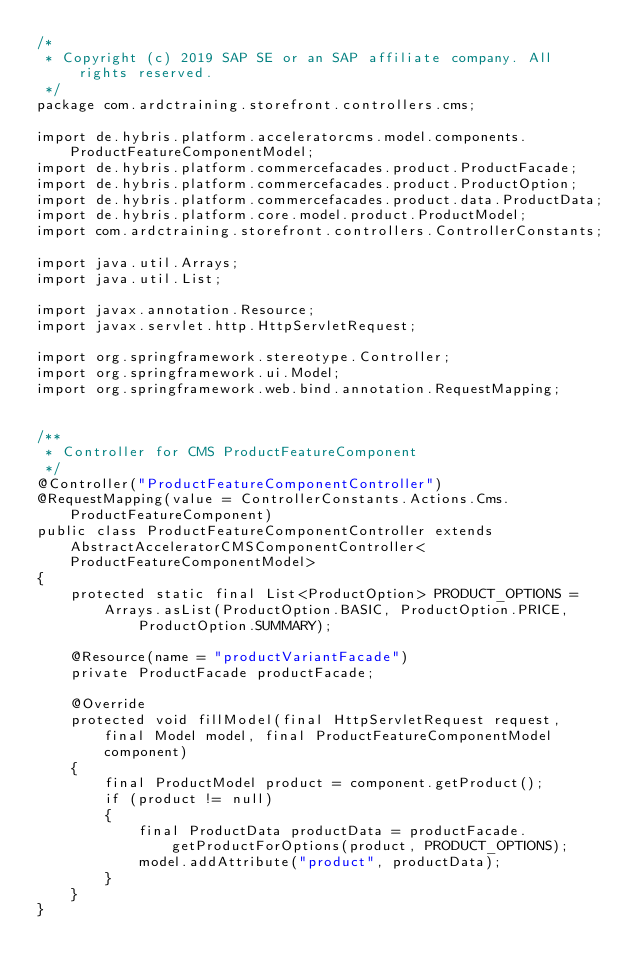Convert code to text. <code><loc_0><loc_0><loc_500><loc_500><_Java_>/*
 * Copyright (c) 2019 SAP SE or an SAP affiliate company. All rights reserved.
 */
package com.ardctraining.storefront.controllers.cms;

import de.hybris.platform.acceleratorcms.model.components.ProductFeatureComponentModel;
import de.hybris.platform.commercefacades.product.ProductFacade;
import de.hybris.platform.commercefacades.product.ProductOption;
import de.hybris.platform.commercefacades.product.data.ProductData;
import de.hybris.platform.core.model.product.ProductModel;
import com.ardctraining.storefront.controllers.ControllerConstants;

import java.util.Arrays;
import java.util.List;

import javax.annotation.Resource;
import javax.servlet.http.HttpServletRequest;

import org.springframework.stereotype.Controller;
import org.springframework.ui.Model;
import org.springframework.web.bind.annotation.RequestMapping;


/**
 * Controller for CMS ProductFeatureComponent
 */
@Controller("ProductFeatureComponentController")
@RequestMapping(value = ControllerConstants.Actions.Cms.ProductFeatureComponent)
public class ProductFeatureComponentController extends AbstractAcceleratorCMSComponentController<ProductFeatureComponentModel>
{
	protected static final List<ProductOption> PRODUCT_OPTIONS = Arrays.asList(ProductOption.BASIC, ProductOption.PRICE,
			ProductOption.SUMMARY);

	@Resource(name = "productVariantFacade")
	private ProductFacade productFacade;

	@Override
	protected void fillModel(final HttpServletRequest request, final Model model, final ProductFeatureComponentModel component)
	{
		final ProductModel product = component.getProduct();
		if (product != null)
		{
			final ProductData productData = productFacade.getProductForOptions(product, PRODUCT_OPTIONS);
			model.addAttribute("product", productData);
		}
	}
}
</code> 